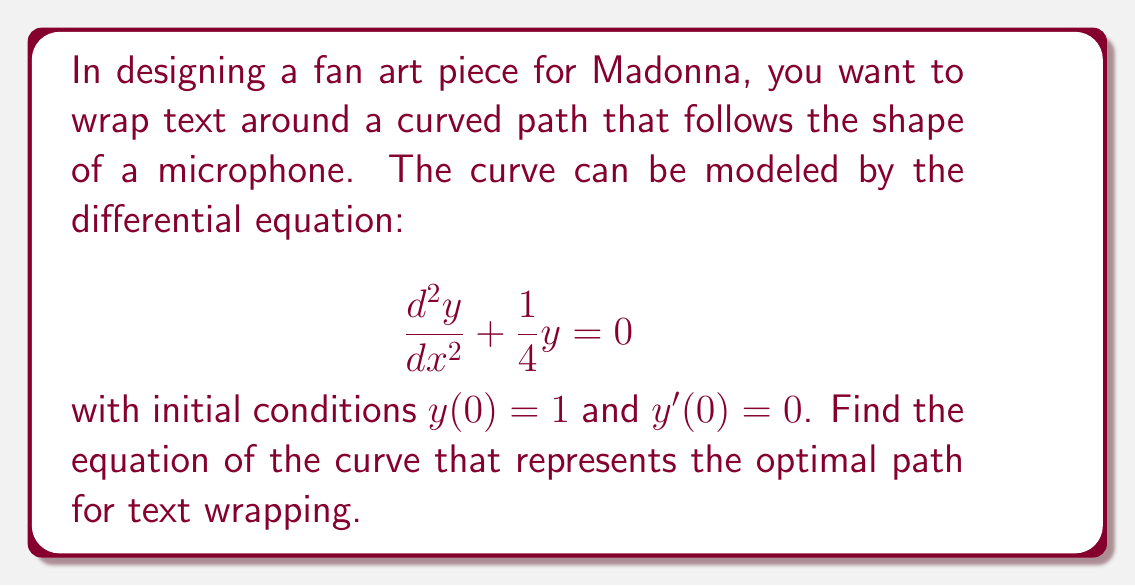Could you help me with this problem? To solve this differential equation, we follow these steps:

1) The given differential equation is a second-order linear homogeneous equation with constant coefficients. Its characteristic equation is:

   $$r^2 + \frac{1}{4} = 0$$

2) Solving this equation:
   $$r = \pm \frac{i}{2}$$

3) The general solution to the differential equation is therefore:

   $$y = C_1 \cos(\frac{x}{2}) + C_2 \sin(\frac{x}{2})$$

4) Now we use the initial conditions to find $C_1$ and $C_2$:

   At $x = 0$, $y(0) = 1$:
   $$1 = C_1 \cos(0) + C_2 \sin(0) = C_1$$

   For $y'(0) = 0$:
   $$y' = -\frac{1}{2}C_1 \sin(\frac{x}{2}) + \frac{1}{2}C_2 \cos(\frac{x}{2})$$
   $$0 = -\frac{1}{2}C_1 \sin(0) + \frac{1}{2}C_2 \cos(0) = \frac{1}{2}C_2$$
   $$C_2 = 0$$

5) Substituting these values back into the general solution:

   $$y = \cos(\frac{x}{2})$$

This equation represents the optimal curve for text wrapping in the fan art design.
Answer: $$y = \cos(\frac{x}{2})$$ 